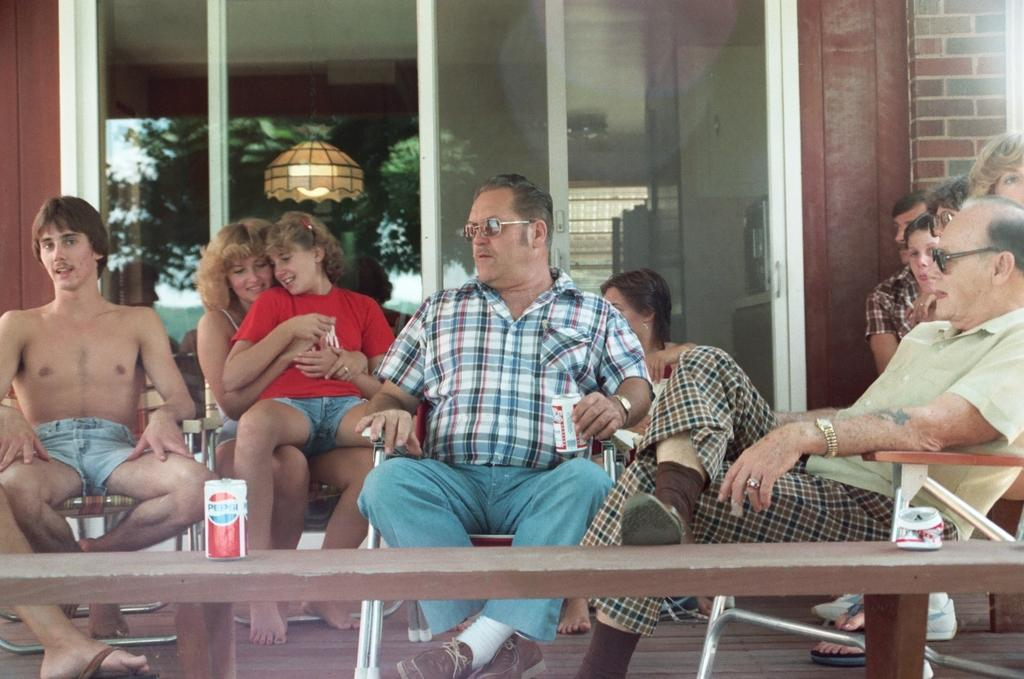What is happening in the image? There is a group of people in the image. How are the people positioned in the image? The people are seated on chairs. What structure can be seen in the image? There is a house in the image. What type of pencil can be seen in the image? There is no pencil present in the image. Is there a mailbox visible near the house in the image? The provided facts do not mention a mailbox, so it cannot be confirmed or denied. 